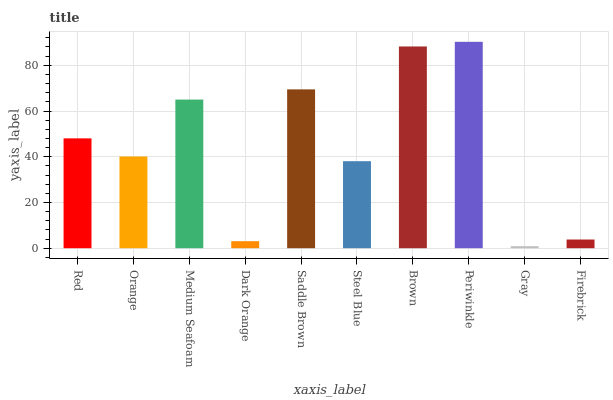Is Orange the minimum?
Answer yes or no. No. Is Orange the maximum?
Answer yes or no. No. Is Red greater than Orange?
Answer yes or no. Yes. Is Orange less than Red?
Answer yes or no. Yes. Is Orange greater than Red?
Answer yes or no. No. Is Red less than Orange?
Answer yes or no. No. Is Red the high median?
Answer yes or no. Yes. Is Orange the low median?
Answer yes or no. Yes. Is Dark Orange the high median?
Answer yes or no. No. Is Firebrick the low median?
Answer yes or no. No. 